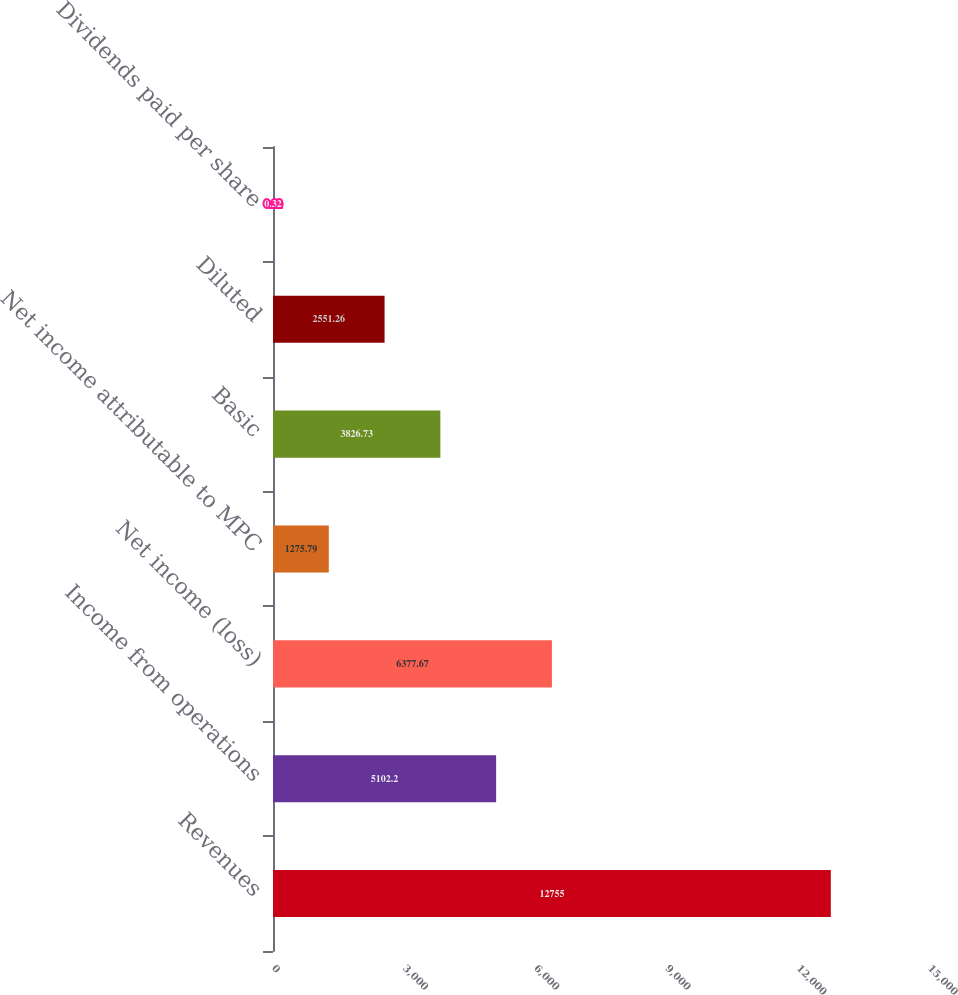Convert chart to OTSL. <chart><loc_0><loc_0><loc_500><loc_500><bar_chart><fcel>Revenues<fcel>Income from operations<fcel>Net income (loss)<fcel>Net income attributable to MPC<fcel>Basic<fcel>Diluted<fcel>Dividends paid per share<nl><fcel>12755<fcel>5102.2<fcel>6377.67<fcel>1275.79<fcel>3826.73<fcel>2551.26<fcel>0.32<nl></chart> 